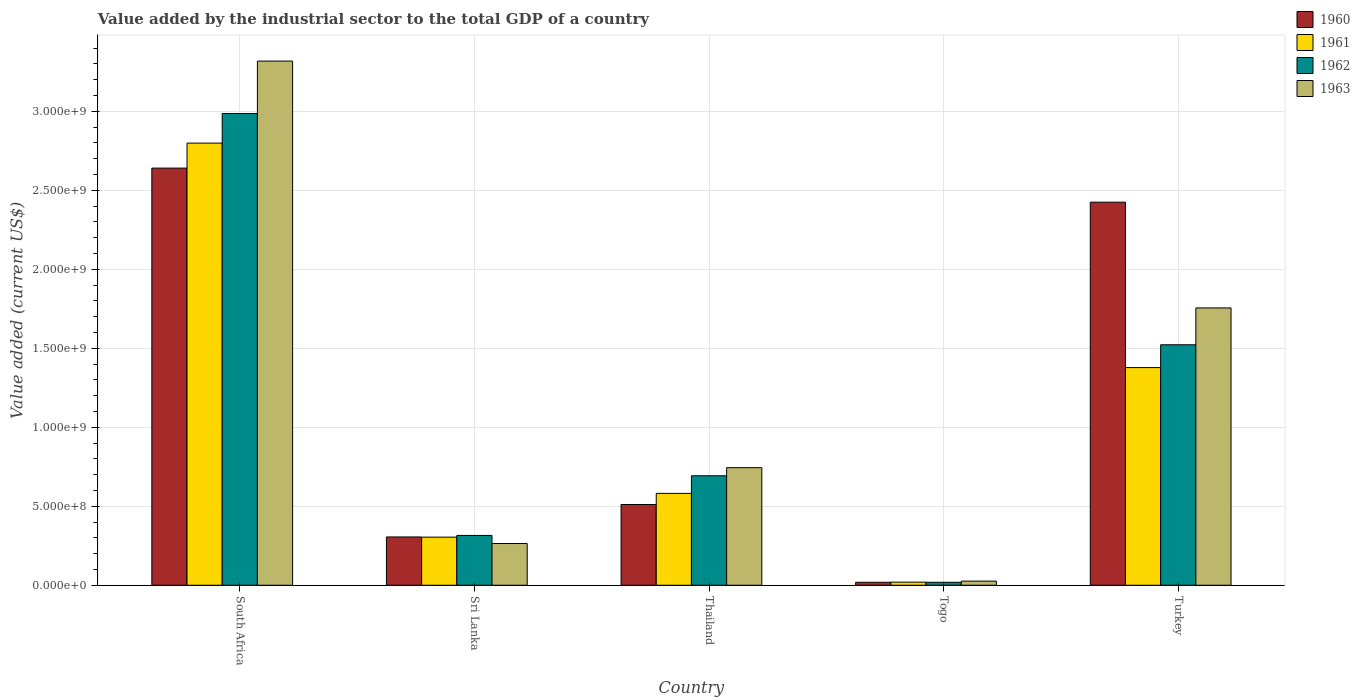Are the number of bars per tick equal to the number of legend labels?
Make the answer very short. Yes. Are the number of bars on each tick of the X-axis equal?
Ensure brevity in your answer.  Yes. What is the label of the 3rd group of bars from the left?
Ensure brevity in your answer.  Thailand. In how many cases, is the number of bars for a given country not equal to the number of legend labels?
Offer a terse response. 0. What is the value added by the industrial sector to the total GDP in 1960 in Sri Lanka?
Ensure brevity in your answer.  3.06e+08. Across all countries, what is the maximum value added by the industrial sector to the total GDP in 1963?
Offer a very short reply. 3.32e+09. Across all countries, what is the minimum value added by the industrial sector to the total GDP in 1960?
Your response must be concise. 1.88e+07. In which country was the value added by the industrial sector to the total GDP in 1962 maximum?
Offer a terse response. South Africa. In which country was the value added by the industrial sector to the total GDP in 1960 minimum?
Your answer should be compact. Togo. What is the total value added by the industrial sector to the total GDP in 1962 in the graph?
Ensure brevity in your answer.  5.54e+09. What is the difference between the value added by the industrial sector to the total GDP in 1960 in South Africa and that in Thailand?
Give a very brief answer. 2.13e+09. What is the difference between the value added by the industrial sector to the total GDP in 1960 in South Africa and the value added by the industrial sector to the total GDP in 1961 in Thailand?
Give a very brief answer. 2.06e+09. What is the average value added by the industrial sector to the total GDP in 1961 per country?
Give a very brief answer. 1.02e+09. What is the difference between the value added by the industrial sector to the total GDP of/in 1961 and value added by the industrial sector to the total GDP of/in 1963 in South Africa?
Ensure brevity in your answer.  -5.19e+08. What is the ratio of the value added by the industrial sector to the total GDP in 1962 in Sri Lanka to that in Turkey?
Your answer should be very brief. 0.21. Is the value added by the industrial sector to the total GDP in 1961 in Togo less than that in Turkey?
Your answer should be very brief. Yes. Is the difference between the value added by the industrial sector to the total GDP in 1961 in Sri Lanka and Thailand greater than the difference between the value added by the industrial sector to the total GDP in 1963 in Sri Lanka and Thailand?
Your response must be concise. Yes. What is the difference between the highest and the second highest value added by the industrial sector to the total GDP in 1961?
Provide a succinct answer. 1.42e+09. What is the difference between the highest and the lowest value added by the industrial sector to the total GDP in 1963?
Provide a succinct answer. 3.29e+09. What does the 2nd bar from the left in Thailand represents?
Your answer should be compact. 1961. What does the 4th bar from the right in Thailand represents?
Your answer should be compact. 1960. How many bars are there?
Your answer should be compact. 20. Are all the bars in the graph horizontal?
Your response must be concise. No. What is the difference between two consecutive major ticks on the Y-axis?
Make the answer very short. 5.00e+08. Does the graph contain any zero values?
Your answer should be compact. No. Does the graph contain grids?
Keep it short and to the point. Yes. How are the legend labels stacked?
Your answer should be very brief. Vertical. What is the title of the graph?
Ensure brevity in your answer.  Value added by the industrial sector to the total GDP of a country. What is the label or title of the Y-axis?
Your response must be concise. Value added (current US$). What is the Value added (current US$) in 1960 in South Africa?
Make the answer very short. 2.64e+09. What is the Value added (current US$) of 1961 in South Africa?
Provide a short and direct response. 2.80e+09. What is the Value added (current US$) in 1962 in South Africa?
Give a very brief answer. 2.99e+09. What is the Value added (current US$) of 1963 in South Africa?
Your response must be concise. 3.32e+09. What is the Value added (current US$) of 1960 in Sri Lanka?
Offer a terse response. 3.06e+08. What is the Value added (current US$) of 1961 in Sri Lanka?
Offer a very short reply. 3.04e+08. What is the Value added (current US$) of 1962 in Sri Lanka?
Offer a very short reply. 3.15e+08. What is the Value added (current US$) of 1963 in Sri Lanka?
Offer a very short reply. 2.64e+08. What is the Value added (current US$) of 1960 in Thailand?
Your answer should be very brief. 5.11e+08. What is the Value added (current US$) in 1961 in Thailand?
Your response must be concise. 5.81e+08. What is the Value added (current US$) in 1962 in Thailand?
Ensure brevity in your answer.  6.93e+08. What is the Value added (current US$) in 1963 in Thailand?
Ensure brevity in your answer.  7.44e+08. What is the Value added (current US$) in 1960 in Togo?
Your answer should be very brief. 1.88e+07. What is the Value added (current US$) in 1961 in Togo?
Give a very brief answer. 1.96e+07. What is the Value added (current US$) of 1962 in Togo?
Provide a succinct answer. 1.88e+07. What is the Value added (current US$) of 1963 in Togo?
Make the answer very short. 2.61e+07. What is the Value added (current US$) in 1960 in Turkey?
Ensure brevity in your answer.  2.42e+09. What is the Value added (current US$) in 1961 in Turkey?
Offer a very short reply. 1.38e+09. What is the Value added (current US$) of 1962 in Turkey?
Provide a short and direct response. 1.52e+09. What is the Value added (current US$) in 1963 in Turkey?
Your answer should be compact. 1.76e+09. Across all countries, what is the maximum Value added (current US$) of 1960?
Your response must be concise. 2.64e+09. Across all countries, what is the maximum Value added (current US$) of 1961?
Your answer should be very brief. 2.80e+09. Across all countries, what is the maximum Value added (current US$) in 1962?
Make the answer very short. 2.99e+09. Across all countries, what is the maximum Value added (current US$) in 1963?
Offer a terse response. 3.32e+09. Across all countries, what is the minimum Value added (current US$) in 1960?
Give a very brief answer. 1.88e+07. Across all countries, what is the minimum Value added (current US$) in 1961?
Give a very brief answer. 1.96e+07. Across all countries, what is the minimum Value added (current US$) of 1962?
Your answer should be very brief. 1.88e+07. Across all countries, what is the minimum Value added (current US$) in 1963?
Your answer should be very brief. 2.61e+07. What is the total Value added (current US$) of 1960 in the graph?
Give a very brief answer. 5.90e+09. What is the total Value added (current US$) in 1961 in the graph?
Your answer should be compact. 5.08e+09. What is the total Value added (current US$) in 1962 in the graph?
Offer a terse response. 5.54e+09. What is the total Value added (current US$) of 1963 in the graph?
Ensure brevity in your answer.  6.11e+09. What is the difference between the Value added (current US$) of 1960 in South Africa and that in Sri Lanka?
Offer a very short reply. 2.33e+09. What is the difference between the Value added (current US$) of 1961 in South Africa and that in Sri Lanka?
Provide a succinct answer. 2.49e+09. What is the difference between the Value added (current US$) in 1962 in South Africa and that in Sri Lanka?
Give a very brief answer. 2.67e+09. What is the difference between the Value added (current US$) of 1963 in South Africa and that in Sri Lanka?
Your response must be concise. 3.05e+09. What is the difference between the Value added (current US$) of 1960 in South Africa and that in Thailand?
Your answer should be very brief. 2.13e+09. What is the difference between the Value added (current US$) in 1961 in South Africa and that in Thailand?
Your answer should be very brief. 2.22e+09. What is the difference between the Value added (current US$) of 1962 in South Africa and that in Thailand?
Give a very brief answer. 2.29e+09. What is the difference between the Value added (current US$) in 1963 in South Africa and that in Thailand?
Your answer should be very brief. 2.57e+09. What is the difference between the Value added (current US$) in 1960 in South Africa and that in Togo?
Provide a short and direct response. 2.62e+09. What is the difference between the Value added (current US$) of 1961 in South Africa and that in Togo?
Keep it short and to the point. 2.78e+09. What is the difference between the Value added (current US$) of 1962 in South Africa and that in Togo?
Your answer should be very brief. 2.97e+09. What is the difference between the Value added (current US$) of 1963 in South Africa and that in Togo?
Ensure brevity in your answer.  3.29e+09. What is the difference between the Value added (current US$) in 1960 in South Africa and that in Turkey?
Offer a very short reply. 2.16e+08. What is the difference between the Value added (current US$) in 1961 in South Africa and that in Turkey?
Your answer should be compact. 1.42e+09. What is the difference between the Value added (current US$) in 1962 in South Africa and that in Turkey?
Provide a short and direct response. 1.46e+09. What is the difference between the Value added (current US$) in 1963 in South Africa and that in Turkey?
Your response must be concise. 1.56e+09. What is the difference between the Value added (current US$) in 1960 in Sri Lanka and that in Thailand?
Your answer should be very brief. -2.06e+08. What is the difference between the Value added (current US$) in 1961 in Sri Lanka and that in Thailand?
Ensure brevity in your answer.  -2.77e+08. What is the difference between the Value added (current US$) in 1962 in Sri Lanka and that in Thailand?
Keep it short and to the point. -3.78e+08. What is the difference between the Value added (current US$) in 1963 in Sri Lanka and that in Thailand?
Make the answer very short. -4.80e+08. What is the difference between the Value added (current US$) of 1960 in Sri Lanka and that in Togo?
Make the answer very short. 2.87e+08. What is the difference between the Value added (current US$) of 1961 in Sri Lanka and that in Togo?
Provide a short and direct response. 2.85e+08. What is the difference between the Value added (current US$) in 1962 in Sri Lanka and that in Togo?
Keep it short and to the point. 2.96e+08. What is the difference between the Value added (current US$) of 1963 in Sri Lanka and that in Togo?
Offer a terse response. 2.38e+08. What is the difference between the Value added (current US$) of 1960 in Sri Lanka and that in Turkey?
Give a very brief answer. -2.12e+09. What is the difference between the Value added (current US$) in 1961 in Sri Lanka and that in Turkey?
Offer a very short reply. -1.07e+09. What is the difference between the Value added (current US$) in 1962 in Sri Lanka and that in Turkey?
Provide a short and direct response. -1.21e+09. What is the difference between the Value added (current US$) of 1963 in Sri Lanka and that in Turkey?
Your response must be concise. -1.49e+09. What is the difference between the Value added (current US$) of 1960 in Thailand and that in Togo?
Offer a terse response. 4.92e+08. What is the difference between the Value added (current US$) of 1961 in Thailand and that in Togo?
Provide a short and direct response. 5.62e+08. What is the difference between the Value added (current US$) in 1962 in Thailand and that in Togo?
Ensure brevity in your answer.  6.74e+08. What is the difference between the Value added (current US$) in 1963 in Thailand and that in Togo?
Give a very brief answer. 7.18e+08. What is the difference between the Value added (current US$) of 1960 in Thailand and that in Turkey?
Make the answer very short. -1.91e+09. What is the difference between the Value added (current US$) of 1961 in Thailand and that in Turkey?
Offer a terse response. -7.96e+08. What is the difference between the Value added (current US$) of 1962 in Thailand and that in Turkey?
Give a very brief answer. -8.29e+08. What is the difference between the Value added (current US$) in 1963 in Thailand and that in Turkey?
Provide a short and direct response. -1.01e+09. What is the difference between the Value added (current US$) of 1960 in Togo and that in Turkey?
Make the answer very short. -2.41e+09. What is the difference between the Value added (current US$) in 1961 in Togo and that in Turkey?
Offer a terse response. -1.36e+09. What is the difference between the Value added (current US$) of 1962 in Togo and that in Turkey?
Give a very brief answer. -1.50e+09. What is the difference between the Value added (current US$) in 1963 in Togo and that in Turkey?
Provide a succinct answer. -1.73e+09. What is the difference between the Value added (current US$) in 1960 in South Africa and the Value added (current US$) in 1961 in Sri Lanka?
Your response must be concise. 2.34e+09. What is the difference between the Value added (current US$) in 1960 in South Africa and the Value added (current US$) in 1962 in Sri Lanka?
Provide a short and direct response. 2.33e+09. What is the difference between the Value added (current US$) of 1960 in South Africa and the Value added (current US$) of 1963 in Sri Lanka?
Make the answer very short. 2.38e+09. What is the difference between the Value added (current US$) in 1961 in South Africa and the Value added (current US$) in 1962 in Sri Lanka?
Provide a succinct answer. 2.48e+09. What is the difference between the Value added (current US$) in 1961 in South Africa and the Value added (current US$) in 1963 in Sri Lanka?
Provide a succinct answer. 2.53e+09. What is the difference between the Value added (current US$) of 1962 in South Africa and the Value added (current US$) of 1963 in Sri Lanka?
Ensure brevity in your answer.  2.72e+09. What is the difference between the Value added (current US$) of 1960 in South Africa and the Value added (current US$) of 1961 in Thailand?
Keep it short and to the point. 2.06e+09. What is the difference between the Value added (current US$) in 1960 in South Africa and the Value added (current US$) in 1962 in Thailand?
Give a very brief answer. 1.95e+09. What is the difference between the Value added (current US$) of 1960 in South Africa and the Value added (current US$) of 1963 in Thailand?
Provide a short and direct response. 1.90e+09. What is the difference between the Value added (current US$) of 1961 in South Africa and the Value added (current US$) of 1962 in Thailand?
Offer a very short reply. 2.11e+09. What is the difference between the Value added (current US$) in 1961 in South Africa and the Value added (current US$) in 1963 in Thailand?
Offer a very short reply. 2.05e+09. What is the difference between the Value added (current US$) of 1962 in South Africa and the Value added (current US$) of 1963 in Thailand?
Provide a succinct answer. 2.24e+09. What is the difference between the Value added (current US$) in 1960 in South Africa and the Value added (current US$) in 1961 in Togo?
Ensure brevity in your answer.  2.62e+09. What is the difference between the Value added (current US$) of 1960 in South Africa and the Value added (current US$) of 1962 in Togo?
Keep it short and to the point. 2.62e+09. What is the difference between the Value added (current US$) in 1960 in South Africa and the Value added (current US$) in 1963 in Togo?
Make the answer very short. 2.61e+09. What is the difference between the Value added (current US$) in 1961 in South Africa and the Value added (current US$) in 1962 in Togo?
Your answer should be very brief. 2.78e+09. What is the difference between the Value added (current US$) of 1961 in South Africa and the Value added (current US$) of 1963 in Togo?
Your answer should be compact. 2.77e+09. What is the difference between the Value added (current US$) in 1962 in South Africa and the Value added (current US$) in 1963 in Togo?
Offer a terse response. 2.96e+09. What is the difference between the Value added (current US$) in 1960 in South Africa and the Value added (current US$) in 1961 in Turkey?
Your answer should be very brief. 1.26e+09. What is the difference between the Value added (current US$) of 1960 in South Africa and the Value added (current US$) of 1962 in Turkey?
Offer a very short reply. 1.12e+09. What is the difference between the Value added (current US$) of 1960 in South Africa and the Value added (current US$) of 1963 in Turkey?
Ensure brevity in your answer.  8.85e+08. What is the difference between the Value added (current US$) in 1961 in South Africa and the Value added (current US$) in 1962 in Turkey?
Your answer should be compact. 1.28e+09. What is the difference between the Value added (current US$) in 1961 in South Africa and the Value added (current US$) in 1963 in Turkey?
Offer a very short reply. 1.04e+09. What is the difference between the Value added (current US$) in 1962 in South Africa and the Value added (current US$) in 1963 in Turkey?
Offer a terse response. 1.23e+09. What is the difference between the Value added (current US$) of 1960 in Sri Lanka and the Value added (current US$) of 1961 in Thailand?
Provide a short and direct response. -2.76e+08. What is the difference between the Value added (current US$) in 1960 in Sri Lanka and the Value added (current US$) in 1962 in Thailand?
Provide a succinct answer. -3.87e+08. What is the difference between the Value added (current US$) of 1960 in Sri Lanka and the Value added (current US$) of 1963 in Thailand?
Give a very brief answer. -4.39e+08. What is the difference between the Value added (current US$) in 1961 in Sri Lanka and the Value added (current US$) in 1962 in Thailand?
Provide a succinct answer. -3.89e+08. What is the difference between the Value added (current US$) in 1961 in Sri Lanka and the Value added (current US$) in 1963 in Thailand?
Your answer should be compact. -4.40e+08. What is the difference between the Value added (current US$) of 1962 in Sri Lanka and the Value added (current US$) of 1963 in Thailand?
Your answer should be very brief. -4.29e+08. What is the difference between the Value added (current US$) in 1960 in Sri Lanka and the Value added (current US$) in 1961 in Togo?
Ensure brevity in your answer.  2.86e+08. What is the difference between the Value added (current US$) in 1960 in Sri Lanka and the Value added (current US$) in 1962 in Togo?
Keep it short and to the point. 2.87e+08. What is the difference between the Value added (current US$) in 1960 in Sri Lanka and the Value added (current US$) in 1963 in Togo?
Your answer should be compact. 2.80e+08. What is the difference between the Value added (current US$) of 1961 in Sri Lanka and the Value added (current US$) of 1962 in Togo?
Offer a very short reply. 2.86e+08. What is the difference between the Value added (current US$) of 1961 in Sri Lanka and the Value added (current US$) of 1963 in Togo?
Your answer should be very brief. 2.78e+08. What is the difference between the Value added (current US$) of 1962 in Sri Lanka and the Value added (current US$) of 1963 in Togo?
Offer a terse response. 2.89e+08. What is the difference between the Value added (current US$) in 1960 in Sri Lanka and the Value added (current US$) in 1961 in Turkey?
Your answer should be compact. -1.07e+09. What is the difference between the Value added (current US$) of 1960 in Sri Lanka and the Value added (current US$) of 1962 in Turkey?
Keep it short and to the point. -1.22e+09. What is the difference between the Value added (current US$) of 1960 in Sri Lanka and the Value added (current US$) of 1963 in Turkey?
Your answer should be very brief. -1.45e+09. What is the difference between the Value added (current US$) of 1961 in Sri Lanka and the Value added (current US$) of 1962 in Turkey?
Provide a short and direct response. -1.22e+09. What is the difference between the Value added (current US$) in 1961 in Sri Lanka and the Value added (current US$) in 1963 in Turkey?
Your answer should be very brief. -1.45e+09. What is the difference between the Value added (current US$) in 1962 in Sri Lanka and the Value added (current US$) in 1963 in Turkey?
Give a very brief answer. -1.44e+09. What is the difference between the Value added (current US$) in 1960 in Thailand and the Value added (current US$) in 1961 in Togo?
Ensure brevity in your answer.  4.92e+08. What is the difference between the Value added (current US$) of 1960 in Thailand and the Value added (current US$) of 1962 in Togo?
Your answer should be compact. 4.92e+08. What is the difference between the Value added (current US$) of 1960 in Thailand and the Value added (current US$) of 1963 in Togo?
Ensure brevity in your answer.  4.85e+08. What is the difference between the Value added (current US$) in 1961 in Thailand and the Value added (current US$) in 1962 in Togo?
Your answer should be very brief. 5.63e+08. What is the difference between the Value added (current US$) of 1961 in Thailand and the Value added (current US$) of 1963 in Togo?
Your answer should be very brief. 5.55e+08. What is the difference between the Value added (current US$) in 1962 in Thailand and the Value added (current US$) in 1963 in Togo?
Provide a succinct answer. 6.67e+08. What is the difference between the Value added (current US$) of 1960 in Thailand and the Value added (current US$) of 1961 in Turkey?
Provide a succinct answer. -8.67e+08. What is the difference between the Value added (current US$) in 1960 in Thailand and the Value added (current US$) in 1962 in Turkey?
Make the answer very short. -1.01e+09. What is the difference between the Value added (current US$) of 1960 in Thailand and the Value added (current US$) of 1963 in Turkey?
Your answer should be very brief. -1.24e+09. What is the difference between the Value added (current US$) in 1961 in Thailand and the Value added (current US$) in 1962 in Turkey?
Your answer should be compact. -9.41e+08. What is the difference between the Value added (current US$) of 1961 in Thailand and the Value added (current US$) of 1963 in Turkey?
Offer a terse response. -1.17e+09. What is the difference between the Value added (current US$) of 1962 in Thailand and the Value added (current US$) of 1963 in Turkey?
Provide a short and direct response. -1.06e+09. What is the difference between the Value added (current US$) of 1960 in Togo and the Value added (current US$) of 1961 in Turkey?
Keep it short and to the point. -1.36e+09. What is the difference between the Value added (current US$) of 1960 in Togo and the Value added (current US$) of 1962 in Turkey?
Offer a very short reply. -1.50e+09. What is the difference between the Value added (current US$) in 1960 in Togo and the Value added (current US$) in 1963 in Turkey?
Keep it short and to the point. -1.74e+09. What is the difference between the Value added (current US$) of 1961 in Togo and the Value added (current US$) of 1962 in Turkey?
Your response must be concise. -1.50e+09. What is the difference between the Value added (current US$) in 1961 in Togo and the Value added (current US$) in 1963 in Turkey?
Give a very brief answer. -1.74e+09. What is the difference between the Value added (current US$) in 1962 in Togo and the Value added (current US$) in 1963 in Turkey?
Provide a short and direct response. -1.74e+09. What is the average Value added (current US$) in 1960 per country?
Make the answer very short. 1.18e+09. What is the average Value added (current US$) in 1961 per country?
Make the answer very short. 1.02e+09. What is the average Value added (current US$) of 1962 per country?
Provide a short and direct response. 1.11e+09. What is the average Value added (current US$) in 1963 per country?
Ensure brevity in your answer.  1.22e+09. What is the difference between the Value added (current US$) of 1960 and Value added (current US$) of 1961 in South Africa?
Make the answer very short. -1.58e+08. What is the difference between the Value added (current US$) of 1960 and Value added (current US$) of 1962 in South Africa?
Make the answer very short. -3.46e+08. What is the difference between the Value added (current US$) in 1960 and Value added (current US$) in 1963 in South Africa?
Ensure brevity in your answer.  -6.78e+08. What is the difference between the Value added (current US$) of 1961 and Value added (current US$) of 1962 in South Africa?
Provide a succinct answer. -1.87e+08. What is the difference between the Value added (current US$) of 1961 and Value added (current US$) of 1963 in South Africa?
Your answer should be compact. -5.19e+08. What is the difference between the Value added (current US$) in 1962 and Value added (current US$) in 1963 in South Africa?
Ensure brevity in your answer.  -3.32e+08. What is the difference between the Value added (current US$) of 1960 and Value added (current US$) of 1961 in Sri Lanka?
Make the answer very short. 1.26e+06. What is the difference between the Value added (current US$) of 1960 and Value added (current US$) of 1962 in Sri Lanka?
Offer a terse response. -9.55e+06. What is the difference between the Value added (current US$) of 1960 and Value added (current US$) of 1963 in Sri Lanka?
Your answer should be compact. 4.16e+07. What is the difference between the Value added (current US$) in 1961 and Value added (current US$) in 1962 in Sri Lanka?
Give a very brief answer. -1.08e+07. What is the difference between the Value added (current US$) in 1961 and Value added (current US$) in 1963 in Sri Lanka?
Your answer should be compact. 4.04e+07. What is the difference between the Value added (current US$) in 1962 and Value added (current US$) in 1963 in Sri Lanka?
Ensure brevity in your answer.  5.12e+07. What is the difference between the Value added (current US$) of 1960 and Value added (current US$) of 1961 in Thailand?
Ensure brevity in your answer.  -7.03e+07. What is the difference between the Value added (current US$) in 1960 and Value added (current US$) in 1962 in Thailand?
Your answer should be compact. -1.82e+08. What is the difference between the Value added (current US$) of 1960 and Value added (current US$) of 1963 in Thailand?
Make the answer very short. -2.33e+08. What is the difference between the Value added (current US$) in 1961 and Value added (current US$) in 1962 in Thailand?
Your answer should be compact. -1.12e+08. What is the difference between the Value added (current US$) in 1961 and Value added (current US$) in 1963 in Thailand?
Offer a terse response. -1.63e+08. What is the difference between the Value added (current US$) in 1962 and Value added (current US$) in 1963 in Thailand?
Ensure brevity in your answer.  -5.15e+07. What is the difference between the Value added (current US$) of 1960 and Value added (current US$) of 1961 in Togo?
Keep it short and to the point. -8.10e+05. What is the difference between the Value added (current US$) in 1960 and Value added (current US$) in 1962 in Togo?
Provide a succinct answer. -1.39e+04. What is the difference between the Value added (current US$) in 1960 and Value added (current US$) in 1963 in Togo?
Provide a succinct answer. -7.36e+06. What is the difference between the Value added (current US$) of 1961 and Value added (current US$) of 1962 in Togo?
Your answer should be very brief. 7.97e+05. What is the difference between the Value added (current US$) in 1961 and Value added (current US$) in 1963 in Togo?
Provide a succinct answer. -6.55e+06. What is the difference between the Value added (current US$) in 1962 and Value added (current US$) in 1963 in Togo?
Offer a very short reply. -7.35e+06. What is the difference between the Value added (current US$) in 1960 and Value added (current US$) in 1961 in Turkey?
Give a very brief answer. 1.05e+09. What is the difference between the Value added (current US$) in 1960 and Value added (current US$) in 1962 in Turkey?
Your answer should be compact. 9.03e+08. What is the difference between the Value added (current US$) in 1960 and Value added (current US$) in 1963 in Turkey?
Your answer should be compact. 6.69e+08. What is the difference between the Value added (current US$) in 1961 and Value added (current US$) in 1962 in Turkey?
Offer a very short reply. -1.44e+08. What is the difference between the Value added (current US$) of 1961 and Value added (current US$) of 1963 in Turkey?
Make the answer very short. -3.78e+08. What is the difference between the Value added (current US$) of 1962 and Value added (current US$) of 1963 in Turkey?
Your response must be concise. -2.33e+08. What is the ratio of the Value added (current US$) of 1960 in South Africa to that in Sri Lanka?
Keep it short and to the point. 8.64. What is the ratio of the Value added (current US$) in 1961 in South Africa to that in Sri Lanka?
Provide a short and direct response. 9.19. What is the ratio of the Value added (current US$) in 1962 in South Africa to that in Sri Lanka?
Give a very brief answer. 9.47. What is the ratio of the Value added (current US$) of 1963 in South Africa to that in Sri Lanka?
Make the answer very short. 12.57. What is the ratio of the Value added (current US$) of 1960 in South Africa to that in Thailand?
Offer a very short reply. 5.17. What is the ratio of the Value added (current US$) in 1961 in South Africa to that in Thailand?
Give a very brief answer. 4.81. What is the ratio of the Value added (current US$) in 1962 in South Africa to that in Thailand?
Give a very brief answer. 4.31. What is the ratio of the Value added (current US$) of 1963 in South Africa to that in Thailand?
Your answer should be very brief. 4.46. What is the ratio of the Value added (current US$) of 1960 in South Africa to that in Togo?
Provide a short and direct response. 140.76. What is the ratio of the Value added (current US$) of 1961 in South Africa to that in Togo?
Give a very brief answer. 143.01. What is the ratio of the Value added (current US$) in 1962 in South Africa to that in Togo?
Offer a terse response. 159.06. What is the ratio of the Value added (current US$) of 1963 in South Africa to that in Togo?
Give a very brief answer. 127.03. What is the ratio of the Value added (current US$) in 1960 in South Africa to that in Turkey?
Your answer should be compact. 1.09. What is the ratio of the Value added (current US$) of 1961 in South Africa to that in Turkey?
Offer a terse response. 2.03. What is the ratio of the Value added (current US$) of 1962 in South Africa to that in Turkey?
Offer a very short reply. 1.96. What is the ratio of the Value added (current US$) in 1963 in South Africa to that in Turkey?
Provide a short and direct response. 1.89. What is the ratio of the Value added (current US$) of 1960 in Sri Lanka to that in Thailand?
Your response must be concise. 0.6. What is the ratio of the Value added (current US$) in 1961 in Sri Lanka to that in Thailand?
Make the answer very short. 0.52. What is the ratio of the Value added (current US$) of 1962 in Sri Lanka to that in Thailand?
Ensure brevity in your answer.  0.45. What is the ratio of the Value added (current US$) of 1963 in Sri Lanka to that in Thailand?
Offer a very short reply. 0.35. What is the ratio of the Value added (current US$) in 1960 in Sri Lanka to that in Togo?
Provide a succinct answer. 16.29. What is the ratio of the Value added (current US$) of 1961 in Sri Lanka to that in Togo?
Offer a terse response. 15.55. What is the ratio of the Value added (current US$) in 1962 in Sri Lanka to that in Togo?
Give a very brief answer. 16.79. What is the ratio of the Value added (current US$) of 1963 in Sri Lanka to that in Togo?
Offer a terse response. 10.11. What is the ratio of the Value added (current US$) of 1960 in Sri Lanka to that in Turkey?
Make the answer very short. 0.13. What is the ratio of the Value added (current US$) of 1961 in Sri Lanka to that in Turkey?
Provide a succinct answer. 0.22. What is the ratio of the Value added (current US$) of 1962 in Sri Lanka to that in Turkey?
Offer a terse response. 0.21. What is the ratio of the Value added (current US$) in 1963 in Sri Lanka to that in Turkey?
Your answer should be very brief. 0.15. What is the ratio of the Value added (current US$) in 1960 in Thailand to that in Togo?
Your response must be concise. 27.25. What is the ratio of the Value added (current US$) of 1961 in Thailand to that in Togo?
Offer a very short reply. 29.71. What is the ratio of the Value added (current US$) of 1962 in Thailand to that in Togo?
Ensure brevity in your answer.  36.91. What is the ratio of the Value added (current US$) in 1960 in Thailand to that in Turkey?
Offer a terse response. 0.21. What is the ratio of the Value added (current US$) in 1961 in Thailand to that in Turkey?
Provide a succinct answer. 0.42. What is the ratio of the Value added (current US$) in 1962 in Thailand to that in Turkey?
Offer a very short reply. 0.46. What is the ratio of the Value added (current US$) in 1963 in Thailand to that in Turkey?
Your answer should be very brief. 0.42. What is the ratio of the Value added (current US$) of 1960 in Togo to that in Turkey?
Provide a succinct answer. 0.01. What is the ratio of the Value added (current US$) in 1961 in Togo to that in Turkey?
Provide a short and direct response. 0.01. What is the ratio of the Value added (current US$) of 1962 in Togo to that in Turkey?
Give a very brief answer. 0.01. What is the ratio of the Value added (current US$) in 1963 in Togo to that in Turkey?
Offer a very short reply. 0.01. What is the difference between the highest and the second highest Value added (current US$) in 1960?
Your answer should be compact. 2.16e+08. What is the difference between the highest and the second highest Value added (current US$) of 1961?
Ensure brevity in your answer.  1.42e+09. What is the difference between the highest and the second highest Value added (current US$) in 1962?
Ensure brevity in your answer.  1.46e+09. What is the difference between the highest and the second highest Value added (current US$) in 1963?
Provide a succinct answer. 1.56e+09. What is the difference between the highest and the lowest Value added (current US$) in 1960?
Your answer should be very brief. 2.62e+09. What is the difference between the highest and the lowest Value added (current US$) of 1961?
Offer a very short reply. 2.78e+09. What is the difference between the highest and the lowest Value added (current US$) of 1962?
Offer a very short reply. 2.97e+09. What is the difference between the highest and the lowest Value added (current US$) in 1963?
Give a very brief answer. 3.29e+09. 